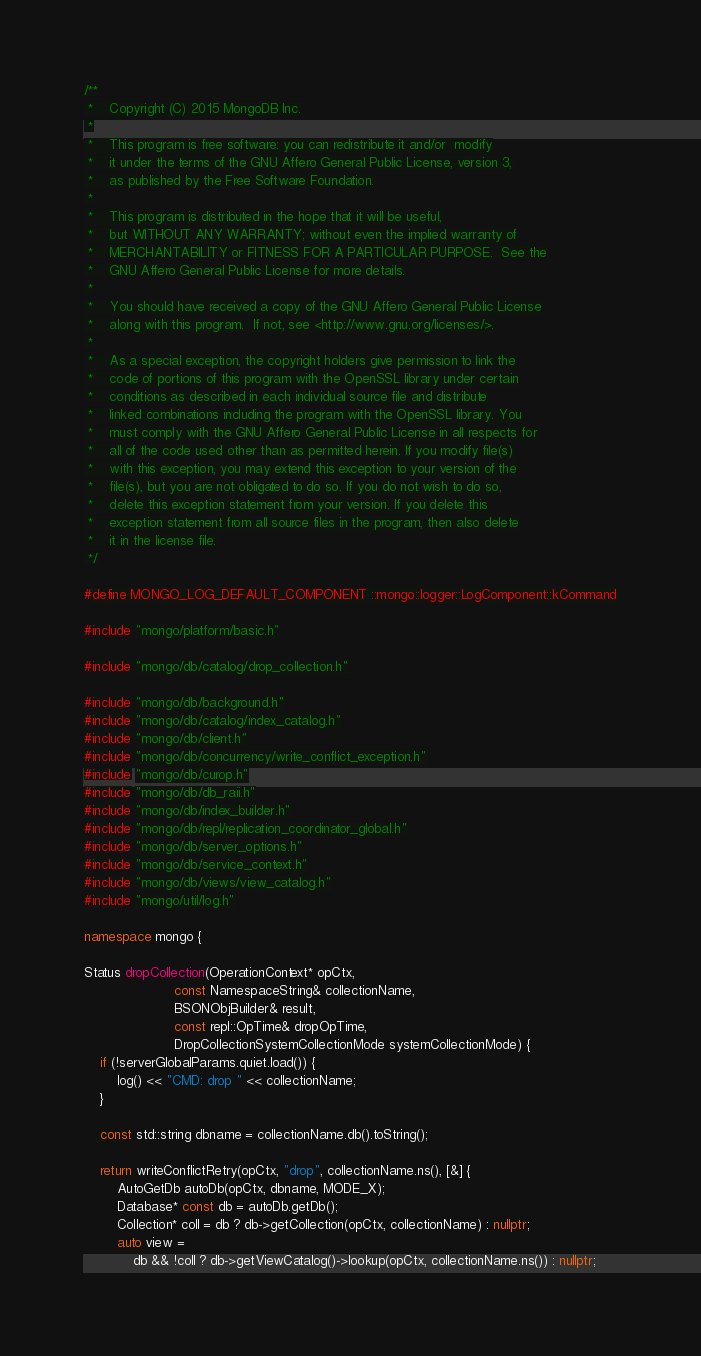Convert code to text. <code><loc_0><loc_0><loc_500><loc_500><_C++_>/**
 *    Copyright (C) 2015 MongoDB Inc.
 *
 *    This program is free software: you can redistribute it and/or  modify
 *    it under the terms of the GNU Affero General Public License, version 3,
 *    as published by the Free Software Foundation.
 *
 *    This program is distributed in the hope that it will be useful,
 *    but WITHOUT ANY WARRANTY; without even the implied warranty of
 *    MERCHANTABILITY or FITNESS FOR A PARTICULAR PURPOSE.  See the
 *    GNU Affero General Public License for more details.
 *
 *    You should have received a copy of the GNU Affero General Public License
 *    along with this program.  If not, see <http://www.gnu.org/licenses/>.
 *
 *    As a special exception, the copyright holders give permission to link the
 *    code of portions of this program with the OpenSSL library under certain
 *    conditions as described in each individual source file and distribute
 *    linked combinations including the program with the OpenSSL library. You
 *    must comply with the GNU Affero General Public License in all respects for
 *    all of the code used other than as permitted herein. If you modify file(s)
 *    with this exception, you may extend this exception to your version of the
 *    file(s), but you are not obligated to do so. If you do not wish to do so,
 *    delete this exception statement from your version. If you delete this
 *    exception statement from all source files in the program, then also delete
 *    it in the license file.
 */

#define MONGO_LOG_DEFAULT_COMPONENT ::mongo::logger::LogComponent::kCommand

#include "mongo/platform/basic.h"

#include "mongo/db/catalog/drop_collection.h"

#include "mongo/db/background.h"
#include "mongo/db/catalog/index_catalog.h"
#include "mongo/db/client.h"
#include "mongo/db/concurrency/write_conflict_exception.h"
#include "mongo/db/curop.h"
#include "mongo/db/db_raii.h"
#include "mongo/db/index_builder.h"
#include "mongo/db/repl/replication_coordinator_global.h"
#include "mongo/db/server_options.h"
#include "mongo/db/service_context.h"
#include "mongo/db/views/view_catalog.h"
#include "mongo/util/log.h"

namespace mongo {

Status dropCollection(OperationContext* opCtx,
                      const NamespaceString& collectionName,
                      BSONObjBuilder& result,
                      const repl::OpTime& dropOpTime,
                      DropCollectionSystemCollectionMode systemCollectionMode) {
    if (!serverGlobalParams.quiet.load()) {
        log() << "CMD: drop " << collectionName;
    }

    const std::string dbname = collectionName.db().toString();

    return writeConflictRetry(opCtx, "drop", collectionName.ns(), [&] {
        AutoGetDb autoDb(opCtx, dbname, MODE_X);
        Database* const db = autoDb.getDb();
        Collection* coll = db ? db->getCollection(opCtx, collectionName) : nullptr;
        auto view =
            db && !coll ? db->getViewCatalog()->lookup(opCtx, collectionName.ns()) : nullptr;
</code> 